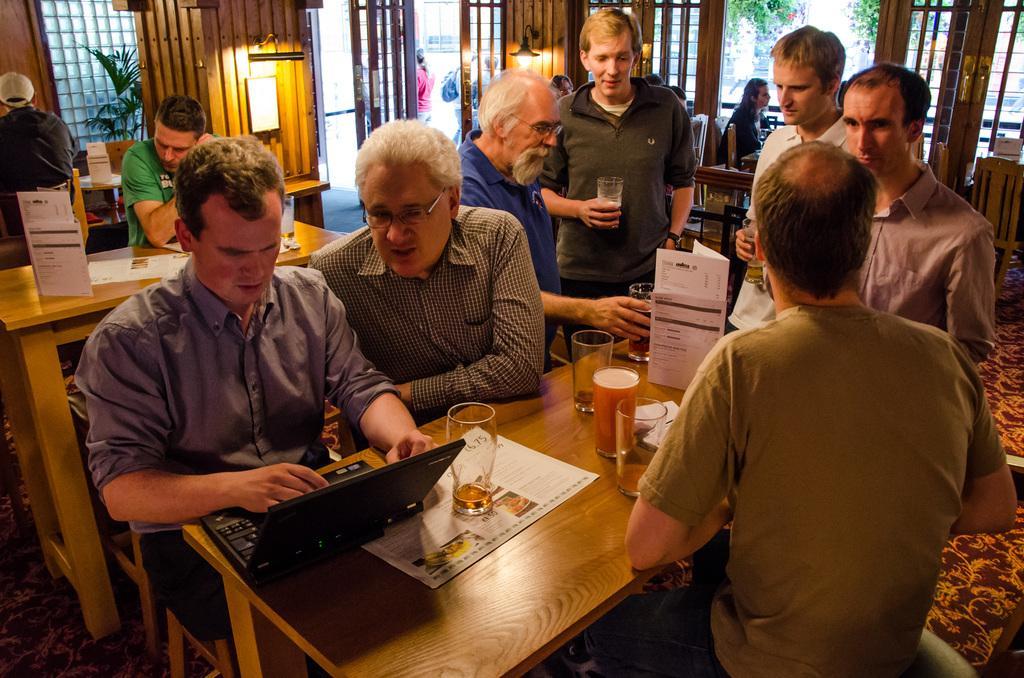In one or two sentences, can you explain what this image depicts? There are two people sitting in the chairs in front of a laptop which was placed on the table along with some glasses here. There are some papers on the table. Some of the people was standing around the table. In the background there are some people sitting and there is a wall here. 